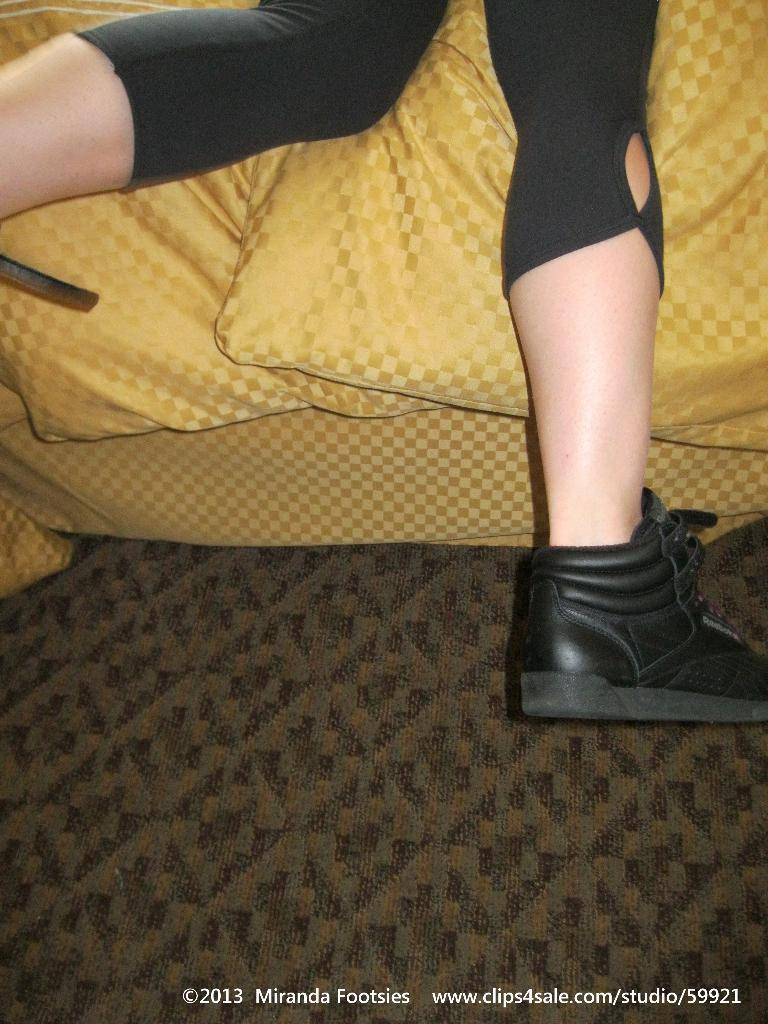What part of a person's body is visible in the image? There is a person's leg in the image. What type of footwear is the person wearing? The person is wearing shoes. Is the person's sister holding a squirrel in the image? There is no person's sister or squirrel present in the image. Is there a gun visible in the image? There is no gun present in the image. 